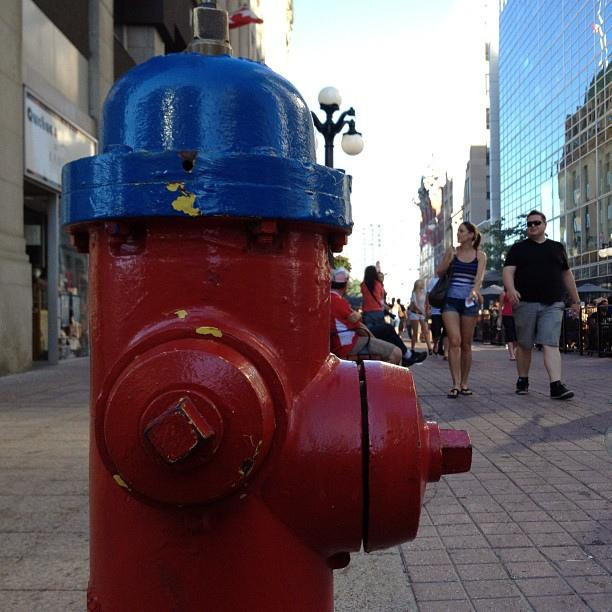What cannot be done in front of this object? Please explain your reasoning. parking. It is a fire hydrant.  vehicles are never allowed to block access to a fire hydrant by stopping in front of one. 